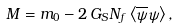Convert formula to latex. <formula><loc_0><loc_0><loc_500><loc_500>M = m _ { 0 } - 2 \, G _ { S } N _ { f } \left \langle \overline { \psi } \psi \right \rangle ,</formula> 